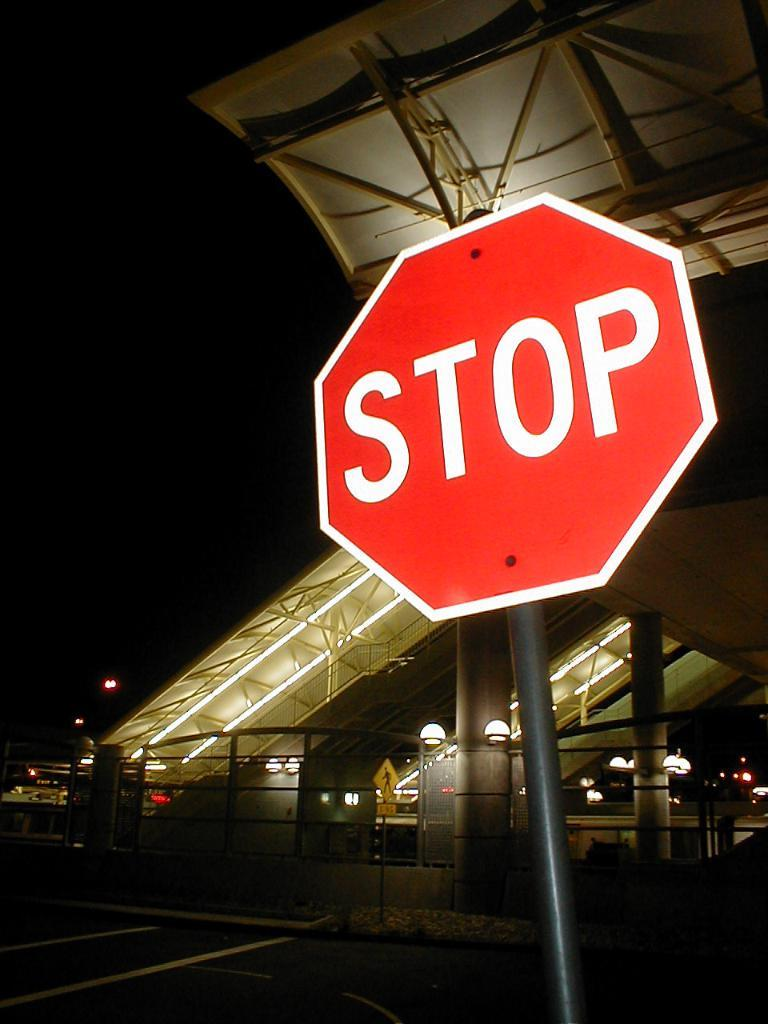<image>
Write a terse but informative summary of the picture. Bright Stop sign in front of a big building 